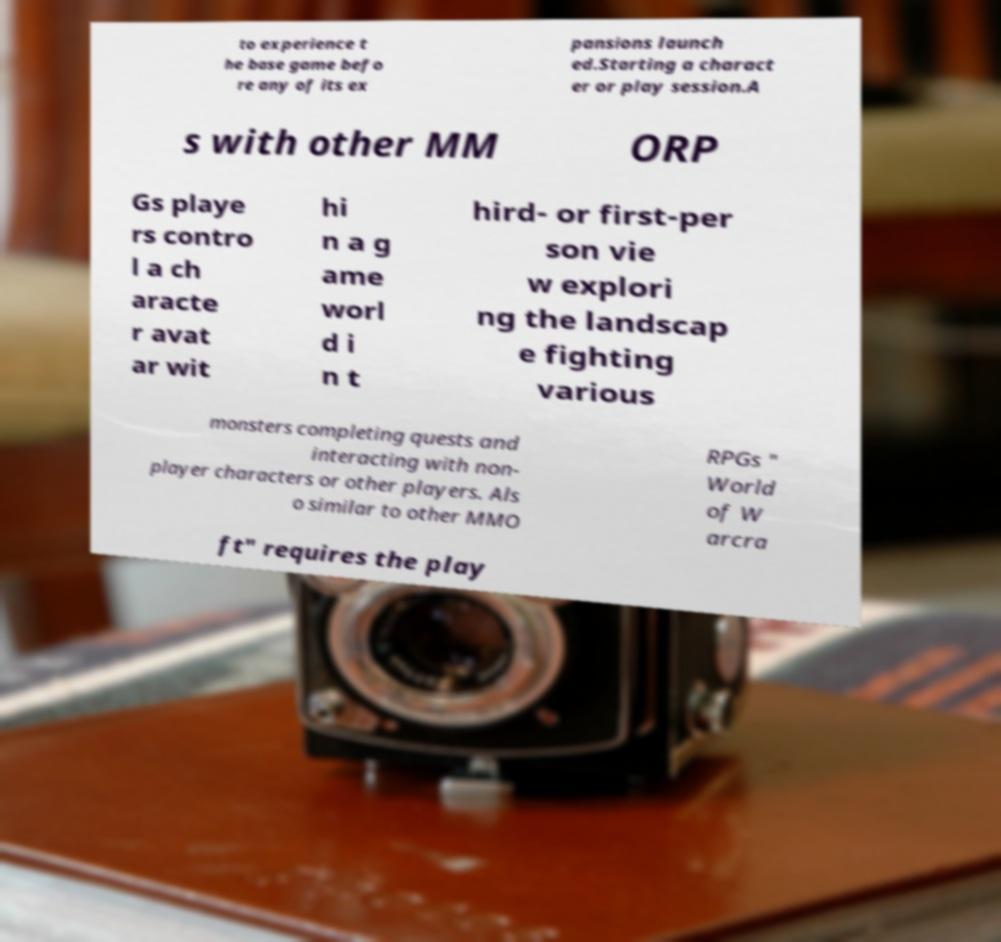I need the written content from this picture converted into text. Can you do that? to experience t he base game befo re any of its ex pansions launch ed.Starting a charact er or play session.A s with other MM ORP Gs playe rs contro l a ch aracte r avat ar wit hi n a g ame worl d i n t hird- or first-per son vie w explori ng the landscap e fighting various monsters completing quests and interacting with non- player characters or other players. Als o similar to other MMO RPGs " World of W arcra ft" requires the play 